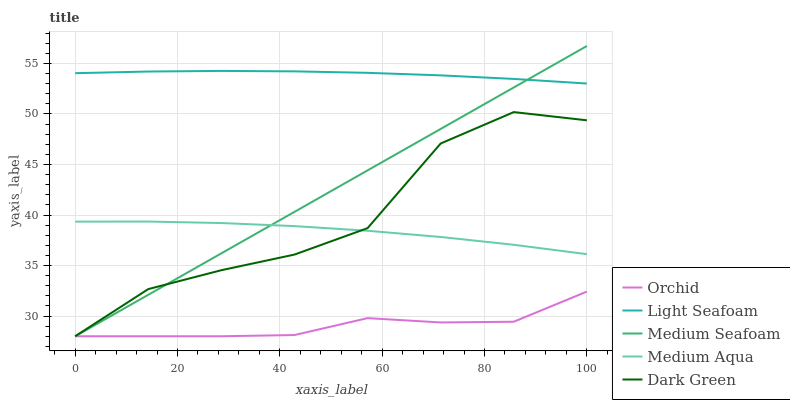Does Orchid have the minimum area under the curve?
Answer yes or no. Yes. Does Light Seafoam have the maximum area under the curve?
Answer yes or no. Yes. Does Medium Aqua have the minimum area under the curve?
Answer yes or no. No. Does Medium Aqua have the maximum area under the curve?
Answer yes or no. No. Is Medium Seafoam the smoothest?
Answer yes or no. Yes. Is Dark Green the roughest?
Answer yes or no. Yes. Is Light Seafoam the smoothest?
Answer yes or no. No. Is Light Seafoam the roughest?
Answer yes or no. No. Does Dark Green have the lowest value?
Answer yes or no. Yes. Does Medium Aqua have the lowest value?
Answer yes or no. No. Does Medium Seafoam have the highest value?
Answer yes or no. Yes. Does Light Seafoam have the highest value?
Answer yes or no. No. Is Dark Green less than Light Seafoam?
Answer yes or no. Yes. Is Light Seafoam greater than Orchid?
Answer yes or no. Yes. Does Medium Seafoam intersect Dark Green?
Answer yes or no. Yes. Is Medium Seafoam less than Dark Green?
Answer yes or no. No. Is Medium Seafoam greater than Dark Green?
Answer yes or no. No. Does Dark Green intersect Light Seafoam?
Answer yes or no. No. 